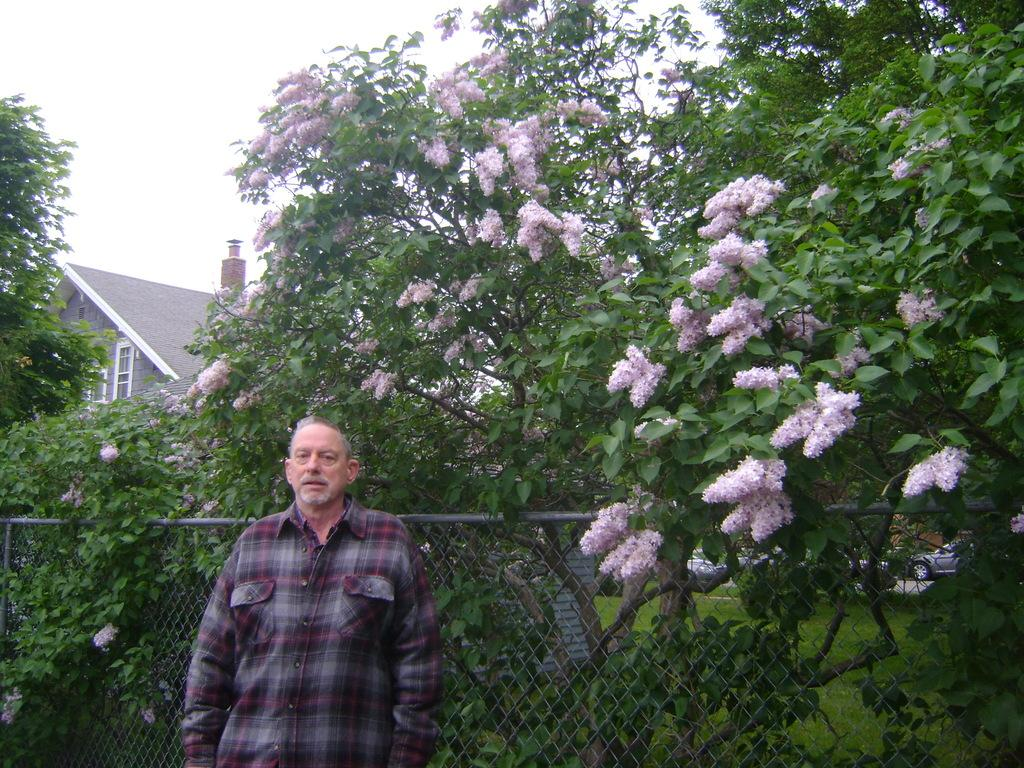What is the main subject in the foreground of the picture? There is a person standing in the foreground of the picture. What can be seen behind the person? There are trees behind the person. What other elements are visible in the background? There are flowers, fencing, grass, and a house in the background. How would you describe the sky in the image? The sky is cloudy in the image. How many sponges are being used to water the garden in the image? There is no garden or sponges present in the image. What color are the eyes of the person in the image? The provided facts do not mention the person's eye color, so it cannot be determined from the image. 